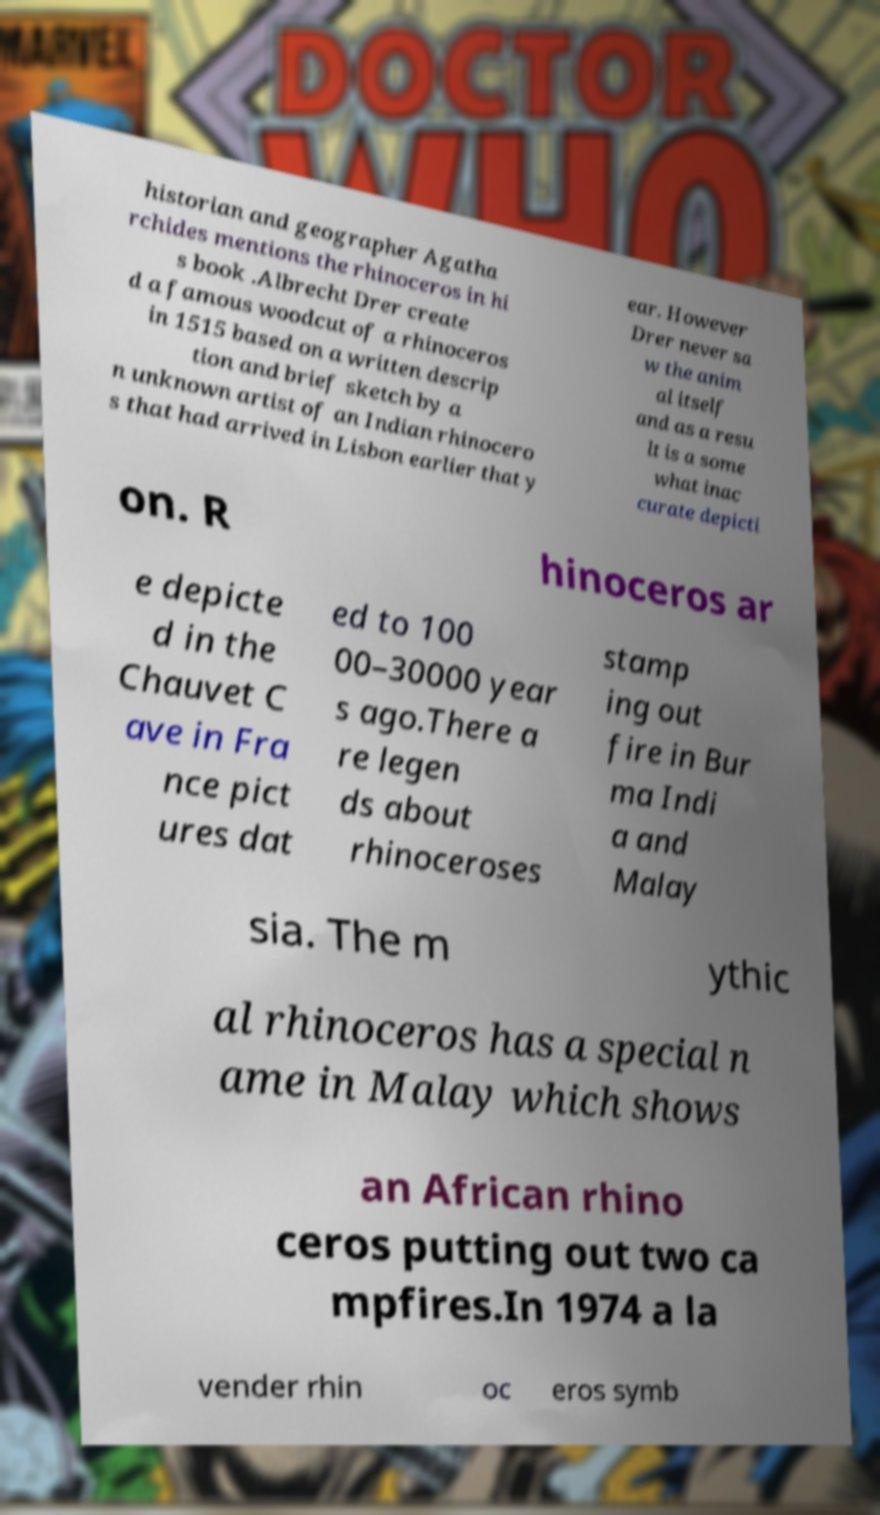There's text embedded in this image that I need extracted. Can you transcribe it verbatim? historian and geographer Agatha rchides mentions the rhinoceros in hi s book .Albrecht Drer create d a famous woodcut of a rhinoceros in 1515 based on a written descrip tion and brief sketch by a n unknown artist of an Indian rhinocero s that had arrived in Lisbon earlier that y ear. However Drer never sa w the anim al itself and as a resu lt is a some what inac curate depicti on. R hinoceros ar e depicte d in the Chauvet C ave in Fra nce pict ures dat ed to 100 00–30000 year s ago.There a re legen ds about rhinoceroses stamp ing out fire in Bur ma Indi a and Malay sia. The m ythic al rhinoceros has a special n ame in Malay which shows an African rhino ceros putting out two ca mpfires.In 1974 a la vender rhin oc eros symb 